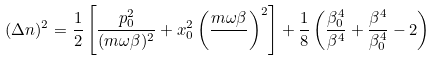<formula> <loc_0><loc_0><loc_500><loc_500>( \Delta n ) ^ { 2 } = \frac { 1 } { 2 } \left [ \frac { p _ { 0 } ^ { 2 } } { ( m \omega \beta ) ^ { 2 } } + x _ { 0 } ^ { 2 } \left ( \frac { m \omega \beta } { } \right ) ^ { 2 } \right ] + \frac { 1 } { 8 } \left ( \frac { \beta _ { 0 } ^ { 4 } } { \beta ^ { 4 } } + \frac { \beta ^ { 4 } } { \beta _ { 0 } ^ { 4 } } - 2 \right )</formula> 